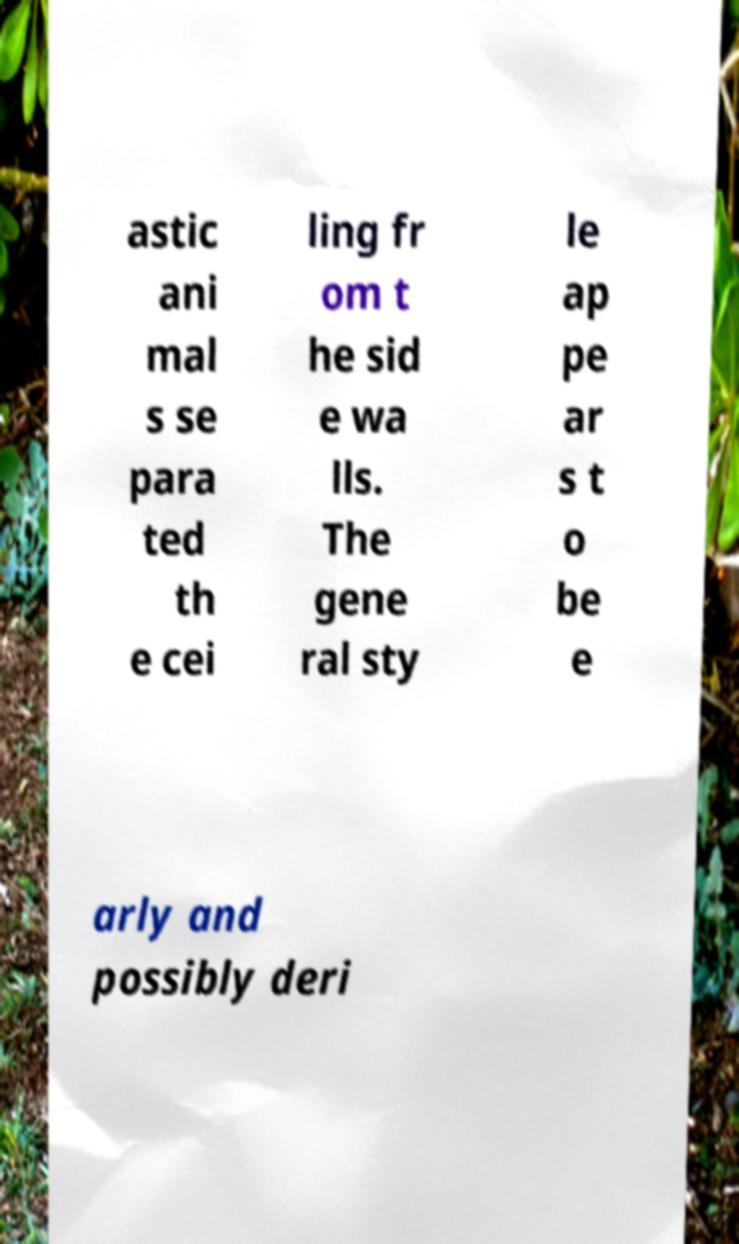Could you assist in decoding the text presented in this image and type it out clearly? astic ani mal s se para ted th e cei ling fr om t he sid e wa lls. The gene ral sty le ap pe ar s t o be e arly and possibly deri 